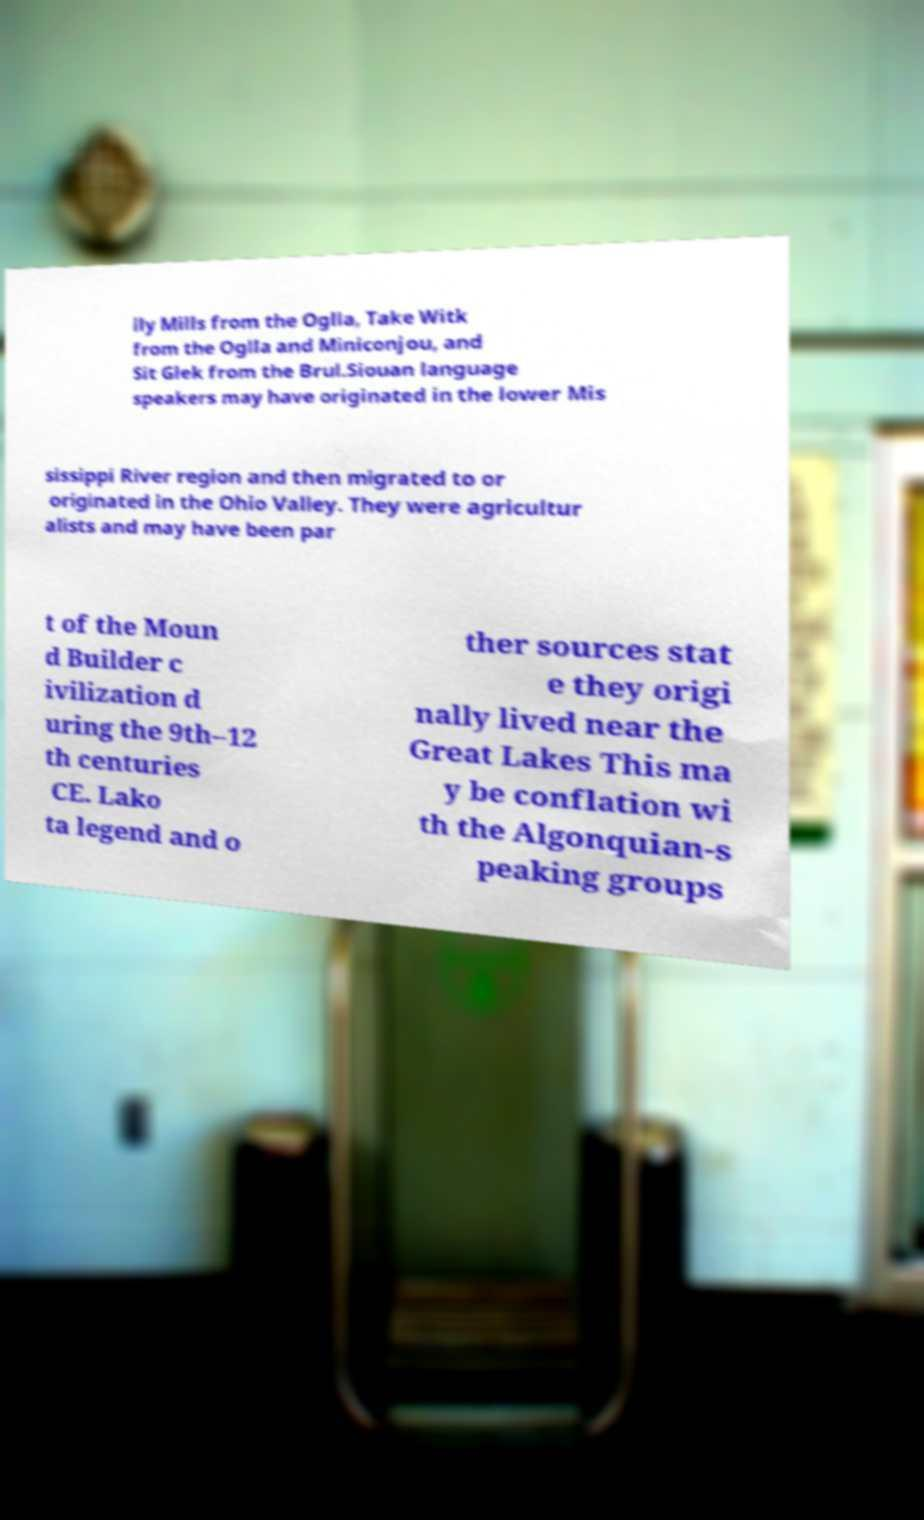Could you assist in decoding the text presented in this image and type it out clearly? lly Mills from the Oglla, Take Witk from the Oglla and Miniconjou, and Sit Glek from the Brul.Siouan language speakers may have originated in the lower Mis sissippi River region and then migrated to or originated in the Ohio Valley. They were agricultur alists and may have been par t of the Moun d Builder c ivilization d uring the 9th–12 th centuries CE. Lako ta legend and o ther sources stat e they origi nally lived near the Great Lakes This ma y be conflation wi th the Algonquian-s peaking groups 